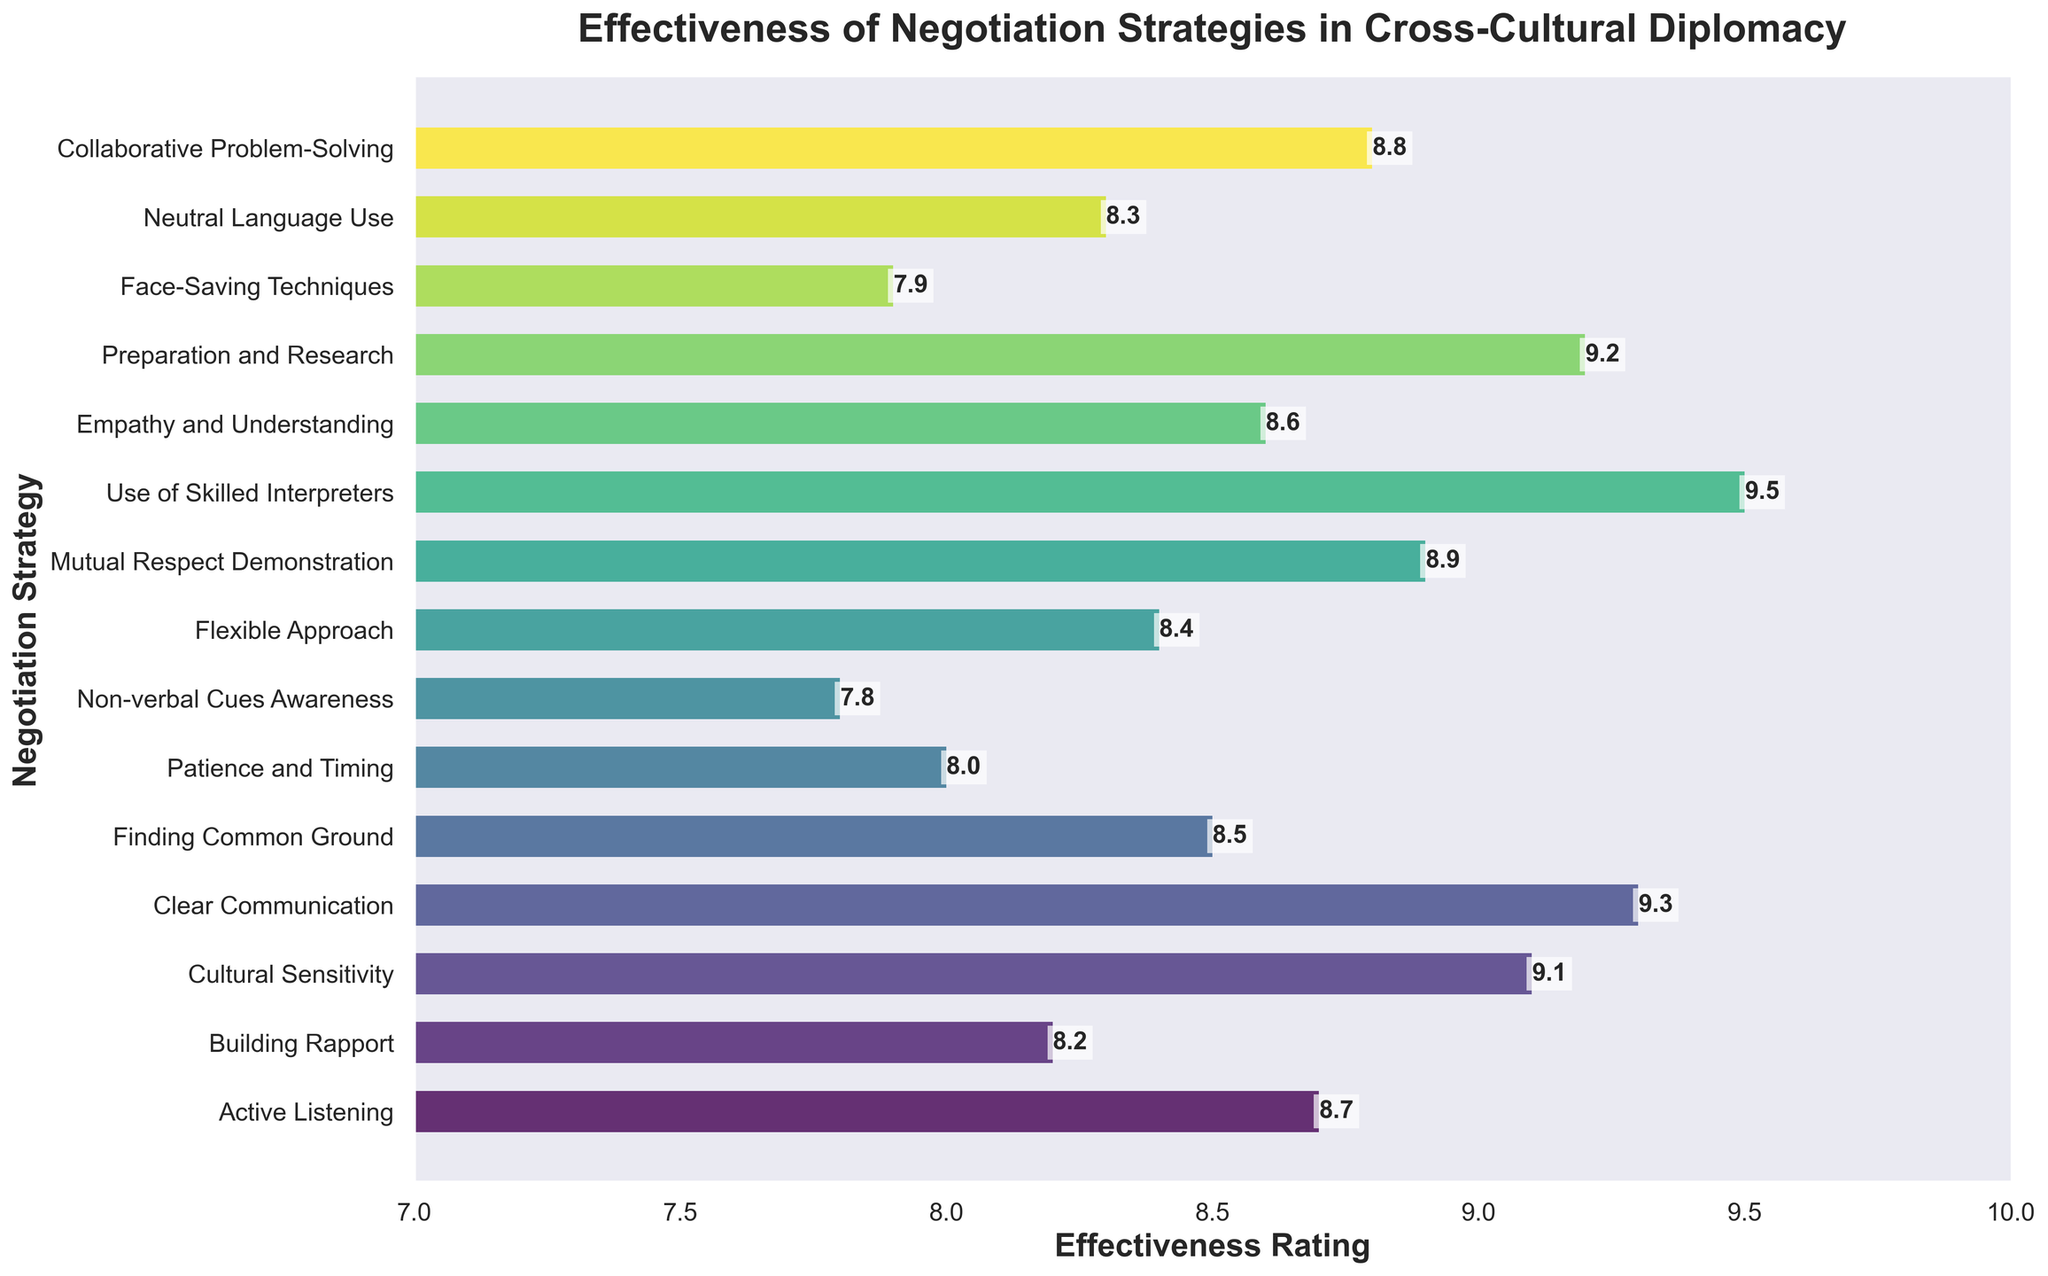What is the most effective negotiation strategy according to the ratings? The most effective negotiation strategy is identified by the highest effectiveness rating. The highest rating is 9.5.
Answer: Use of Skilled Interpreters Which negotiation strategy has the lowest effectiveness rating? To identify the least effective strategy, find the lowest effectiveness rating on the chart. The lowest rating is 7.8.
Answer: Non-verbal Cues Awareness What is the difference in effectiveness rating between 'Clear Communication' and 'Non-verbal Cues Awareness'? Subtract the effectiveness rating of 'Non-verbal Cues Awareness' (7.8) from that of 'Clear Communication' (9.3). 9.3 - 7.8 = 1.5
Answer: 1.5 Among ‘Building Rapport’, ‘Finding Common Ground’, and ‘Neutral Language Use’, which strategy is rated highest? Compare the effectiveness ratings of the three strategies: Building Rapport (8.2), Finding Common Ground (8.5), and Neutral Language Use (8.3). The highest rating is 8.5.
Answer: Finding Common Ground What is the average effectiveness rating of the strategies that have a rating above 9? Identify the ratings above 9: Cultural Sensitivity (9.1), Clear Communication (9.3), Use of Skilled Interpreters (9.5), and Preparation and Research (9.2). Calculate the average: (9.1 + 9.3 + 9.5 + 9.2) / 4 = 9.275
Answer: 9.275 Which two strategies have the closest effectiveness ratings? To find the closest ratings, inspect the ratings that have the smallest difference. 'Active Listening' (8.7) and 'Empathy and Understanding' (8.6) have a difference of 0.1.
Answer: Active Listening and Empathy and Understanding Are there any strategies with an effectiveness rating of exactly 8? Check the figure to see if any strategy has a rating of exactly 8. There is one strategy with this rating.
Answer: Patience and Timing Which strategies have an effectiveness rating higher than 'Flexible Approach'? ‘Flexible Approach’ has a rating of 8.4. Identify all strategies with ratings higher than 8.4: Active Listening (8.7), Cultural Sensitivity (9.1), Clear Communication (9.3), Mutual Respect Demonstration (8.9), Use of Skilled Interpreters (9.5), Empathy and Understanding (8.6), Preparation and Research (9.2), Collaborative Problem-Solving (8.8).
Answer: Active Listening, Cultural Sensitivity, Clear Communication, Mutual Respect Demonstration, Use of Skilled Interpreters, Empathy and Understanding, Preparation and Research, Collaborative Problem-Solving 